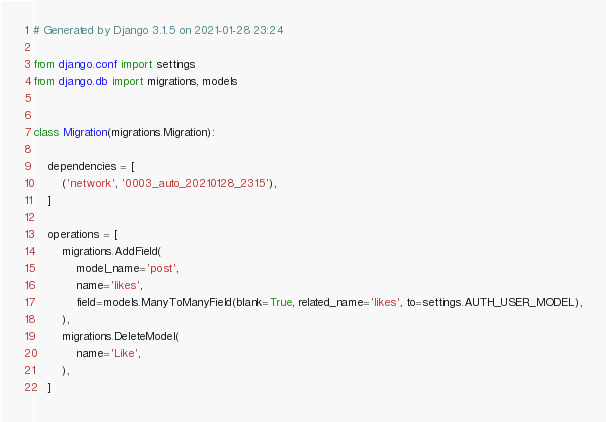<code> <loc_0><loc_0><loc_500><loc_500><_Python_># Generated by Django 3.1.5 on 2021-01-28 23:24

from django.conf import settings
from django.db import migrations, models


class Migration(migrations.Migration):

    dependencies = [
        ('network', '0003_auto_20210128_2315'),
    ]

    operations = [
        migrations.AddField(
            model_name='post',
            name='likes',
            field=models.ManyToManyField(blank=True, related_name='likes', to=settings.AUTH_USER_MODEL),
        ),
        migrations.DeleteModel(
            name='Like',
        ),
    ]
</code> 